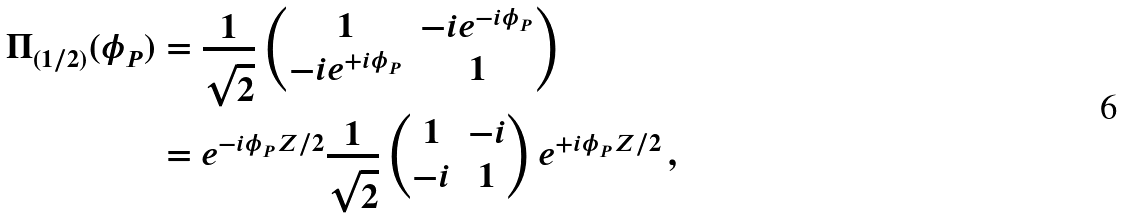<formula> <loc_0><loc_0><loc_500><loc_500>\Pi _ { ( 1 / 2 ) } ( \phi _ { P } ) & = \frac { 1 } { \sqrt { 2 } } \begin{pmatrix} 1 & - i e ^ { - i \phi _ { P } } \\ - i e ^ { + i \phi _ { P } } & 1 \end{pmatrix} \\ & = e ^ { - i \phi _ { P } Z / 2 } \frac { 1 } { \sqrt { 2 } } \begin{pmatrix} 1 & - i \\ - i & 1 \end{pmatrix} e ^ { + i \phi _ { P } Z / 2 } \, ,</formula> 